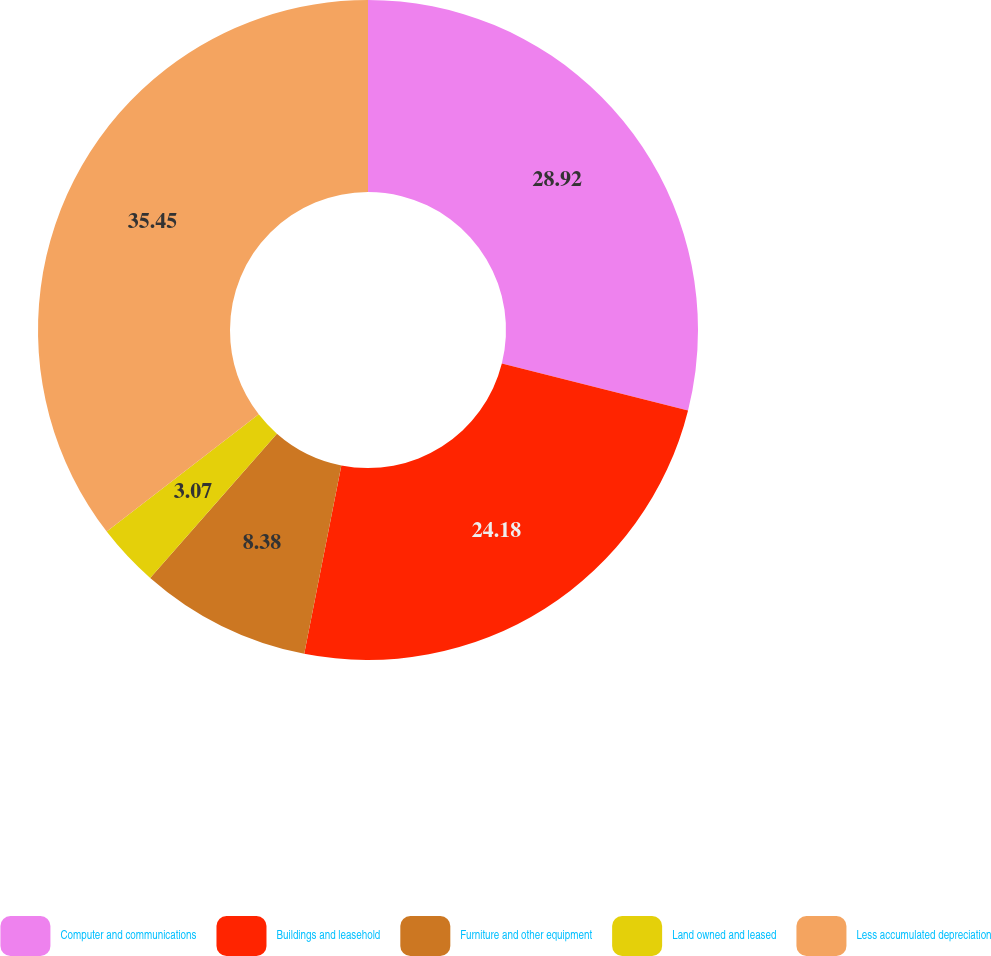Convert chart. <chart><loc_0><loc_0><loc_500><loc_500><pie_chart><fcel>Computer and communications<fcel>Buildings and leasehold<fcel>Furniture and other equipment<fcel>Land owned and leased<fcel>Less accumulated depreciation<nl><fcel>28.92%<fcel>24.18%<fcel>8.38%<fcel>3.07%<fcel>35.46%<nl></chart> 